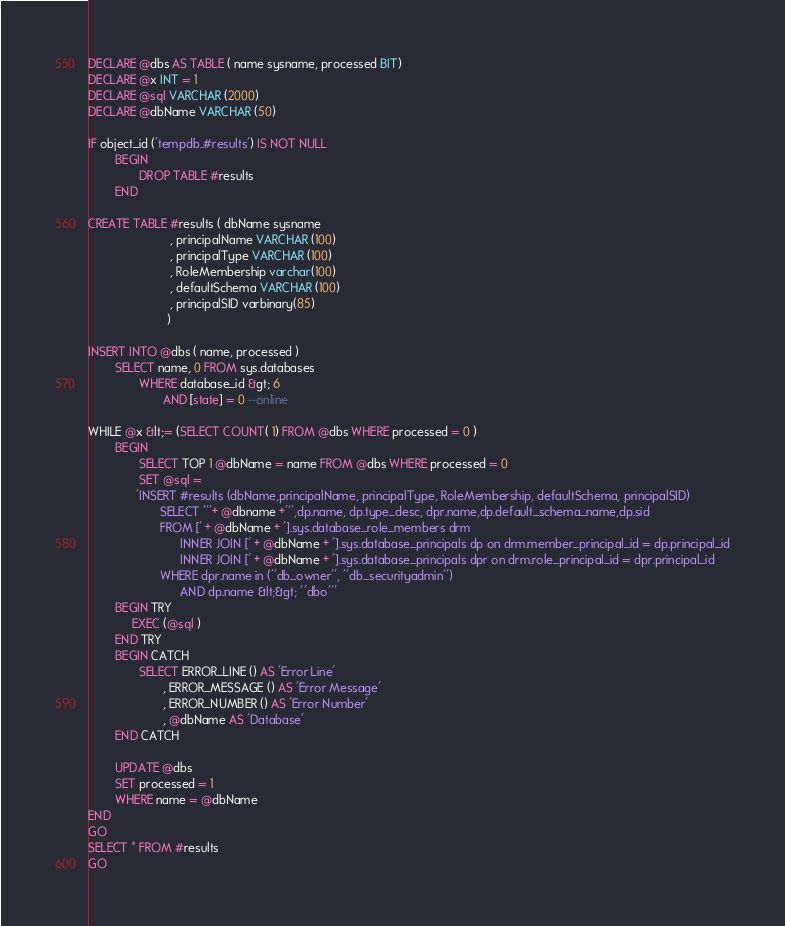<code> <loc_0><loc_0><loc_500><loc_500><_SQL_>
DECLARE @dbs AS TABLE ( name sysname, processed BIT)
DECLARE @x INT = 1
DECLARE @sql VARCHAR (2000)
DECLARE @dbName VARCHAR (50)

IF object_id ('tempdb..#results') IS NOT NULL
        BEGIN
               DROP TABLE #results
        END

CREATE TABLE #results ( dbName sysname
                        , principalName VARCHAR (100)
                        , principalType VARCHAR (100)
                        , RoleMembership varchar(100)
                        , defaultSchema VARCHAR (100)
                        , principalSID varbinary(85)
                       )

INSERT INTO @dbs ( name, processed )
        SELECT name, 0 FROM sys.databases
               WHERE database_id &gt; 6
                      AND [state] = 0 --online

WHILE @x &lt;= (SELECT COUNT( 1) FROM @dbs WHERE processed = 0 )
        BEGIN
               SELECT TOP 1 @dbName = name FROM @dbs WHERE processed = 0
               SET @sql =
              'INSERT #results (dbName,principalName, principalType, RoleMembership, defaultSchema, principalSID)
                     SELECT '''+ @dbname +''',dp.name, dp.type_desc, dpr.name,dp.default_schema_name,dp.sid
                     FROM [' + @dbName + '].sys.database_role_members drm
                           INNER JOIN [' + @dbName + '].sys.database_principals dp on drm.member_principal_id = dp.principal_id
                           INNER JOIN [' + @dbName + '].sys.database_principals dpr on drm.role_principal_id = dpr.principal_id
                     WHERE dpr.name in (''db_owner'', ''db_securityadmin'')
                           AND dp.name &lt;&gt; ''dbo'''
        BEGIN TRY
             EXEC (@sql )
        END TRY
        BEGIN CATCH
               SELECT ERROR_LINE () AS 'Error Line'
                      , ERROR_MESSAGE () AS 'Error Message'
                      , ERROR_NUMBER () AS 'Error Number'
                      , @dbName AS 'Database'
        END CATCH

        UPDATE @dbs
        SET processed = 1
        WHERE name = @dbName
END
GO
SELECT * FROM #results
GO</code> 